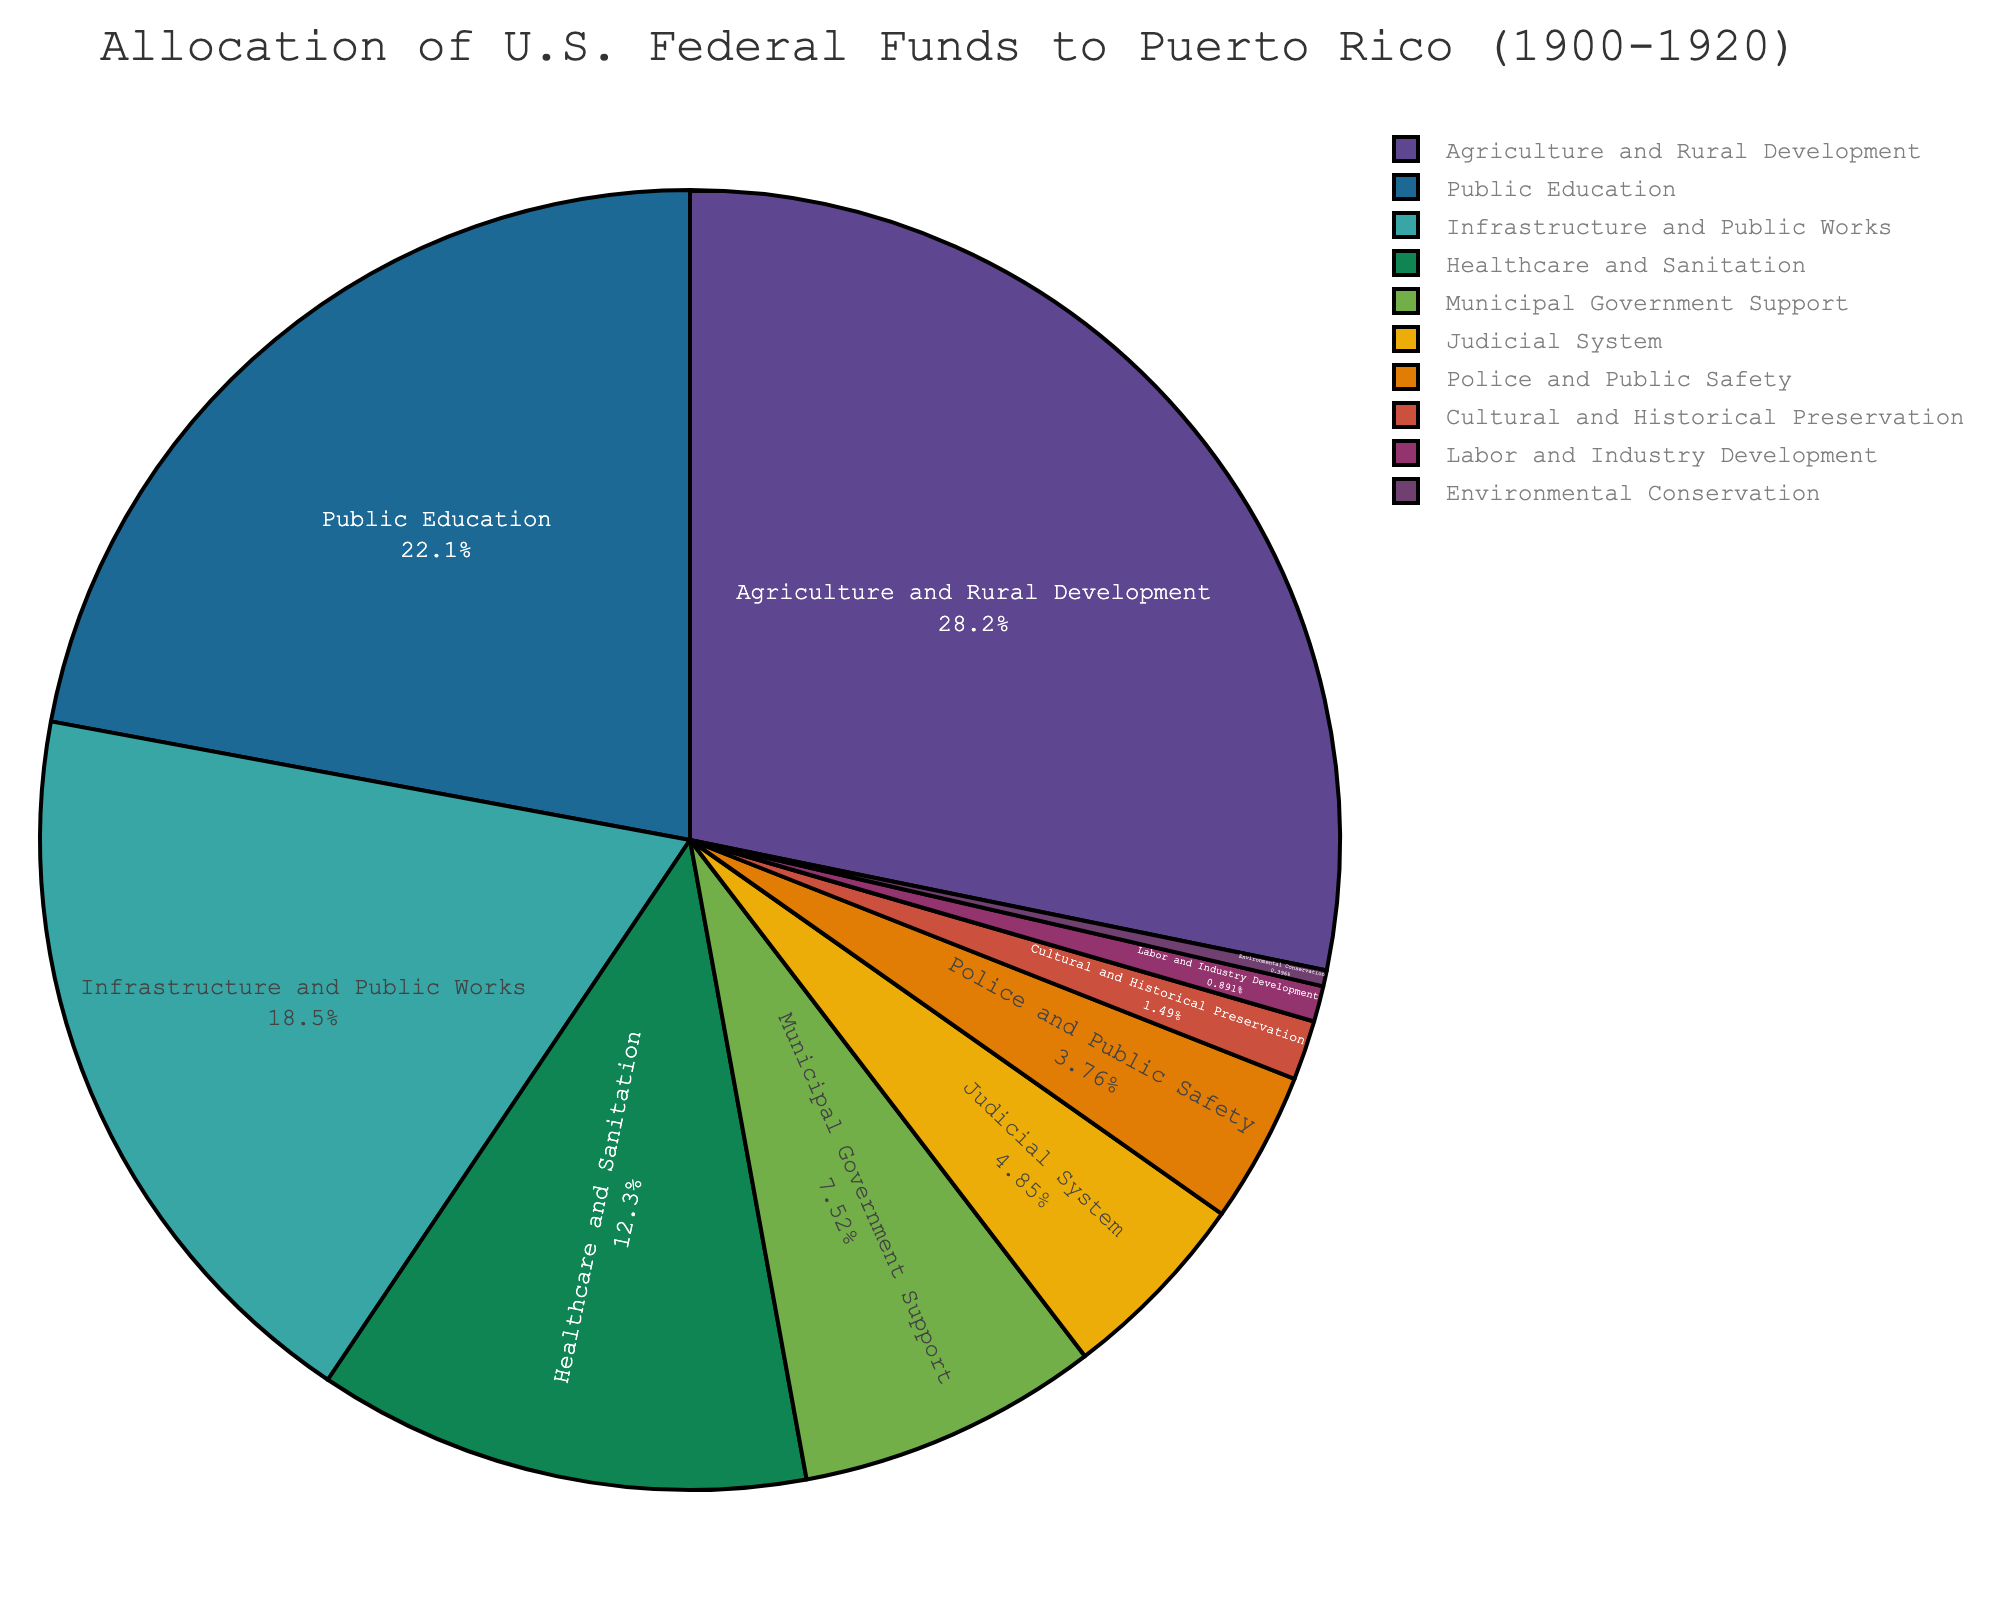What sector received the highest percentage of U.S. federal funds in Puerto Rico from 1900-1920? The pie chart shows various sectors with their corresponding allocation percentages. The sector with the largest slice represents the highest allocation, which is Agriculture and Rural Development at 28.5%.
Answer: Agriculture and Rural Development Which two sectors received the most similar percentage of U.S. federal funds? By comparing the allocation percentages, Public Education received 22.3% of the funds, and Infrastructure and Public Works received 18.7%. These are the two closest percentages.
Answer: Public Education and Infrastructure and Public Works What is the combined percentage of funds allocated to Agriculture and Rural Development, and Healthcare and Sanitation? From the pie chart, Agriculture and Rural Development received 28.5% and Healthcare and Sanitation received 12.4%. Sum of these percentages: 28.5 + 12.4 = 40.9%.
Answer: 40.9% Which sectors received less than 5% of the U.S. federal funds? Identifying the slices representing less than 5% allocation, we see Judicial System (4.9%), Police and Public Safety (3.8%), Cultural and Historical Preservation (1.5%), Labor and Industry Development (0.9%), and Environmental Conservation (0.4%).
Answer: Judicial System, Police and Public Safety, Cultural and Historical Preservation, Labor and Industry Development, Environmental Conservation How much more percentage of funds did Healthcare and Sanitation receive compared to Municipal Government Support? The pie chart shows Healthcare and Sanitation received 12.4% while Municipal Government Support received 7.6%. Difference: 12.4 - 7.6 = 4.8%.
Answer: 4.8% What is the total percentage of funds allocated to sectors related to public services (e.g., Public Education, Healthcare and Sanitation, Infrastructure and Public Works)? Public services sectors include Public Education (22.3%), Healthcare and Sanitation (12.4%), and Infrastructure and Public Works (18.7%). Sum: 22.3 + 12.4 + 18.7 = 53.4%.
Answer: 53.4% Which sector received almost twice the percentage of funds as Police and Public Safety? Police and Public Safety received 3.8%. The pie chart shows that Municipal Government Support, which received 7.6%, is almost twice that amount (3.8 * 2 = 7.6).
Answer: Municipal Government Support What is the least funded sector according to the pie chart? By looking at the smallest slice in the pie chart, Environmental Conservation, which received 0.4%, is the least funded sector.
Answer: Environmental Conservation Compare the allocation percentages for Cultural and Historical Preservation and Labor and Industry Development. Which one received more funds, and by how much? Cultural and Historical Preservation received 1.5%, while Labor and Industry Development received 0.9%. Difference: 1.5 - 0.9 = 0.6%.
Answer: Cultural and Historical Preservation; 0.6% 